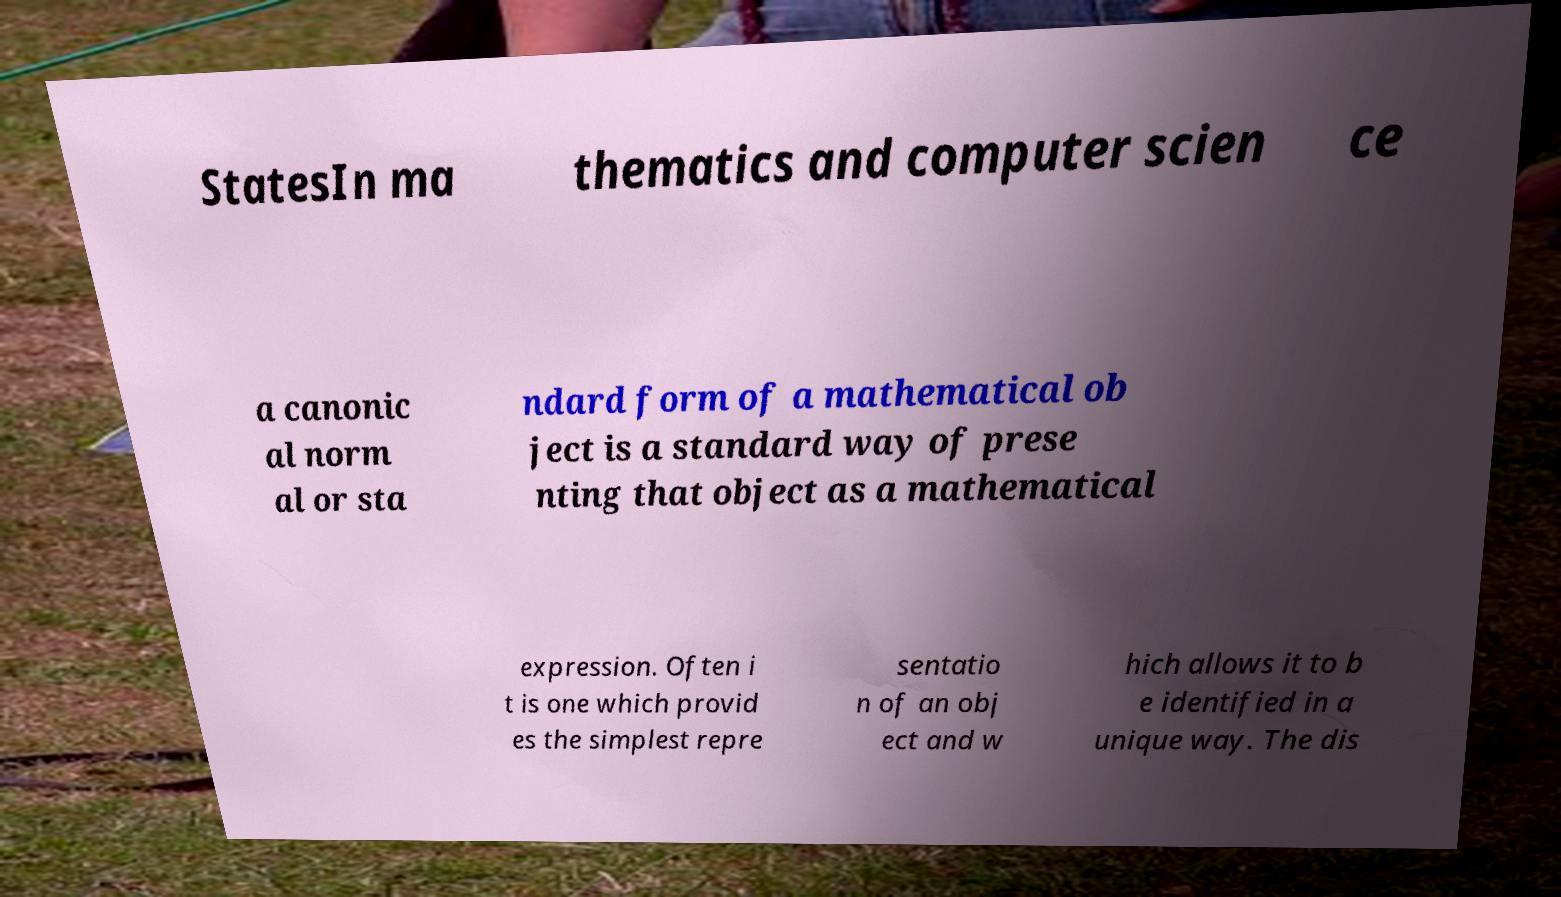Can you accurately transcribe the text from the provided image for me? StatesIn ma thematics and computer scien ce a canonic al norm al or sta ndard form of a mathematical ob ject is a standard way of prese nting that object as a mathematical expression. Often i t is one which provid es the simplest repre sentatio n of an obj ect and w hich allows it to b e identified in a unique way. The dis 